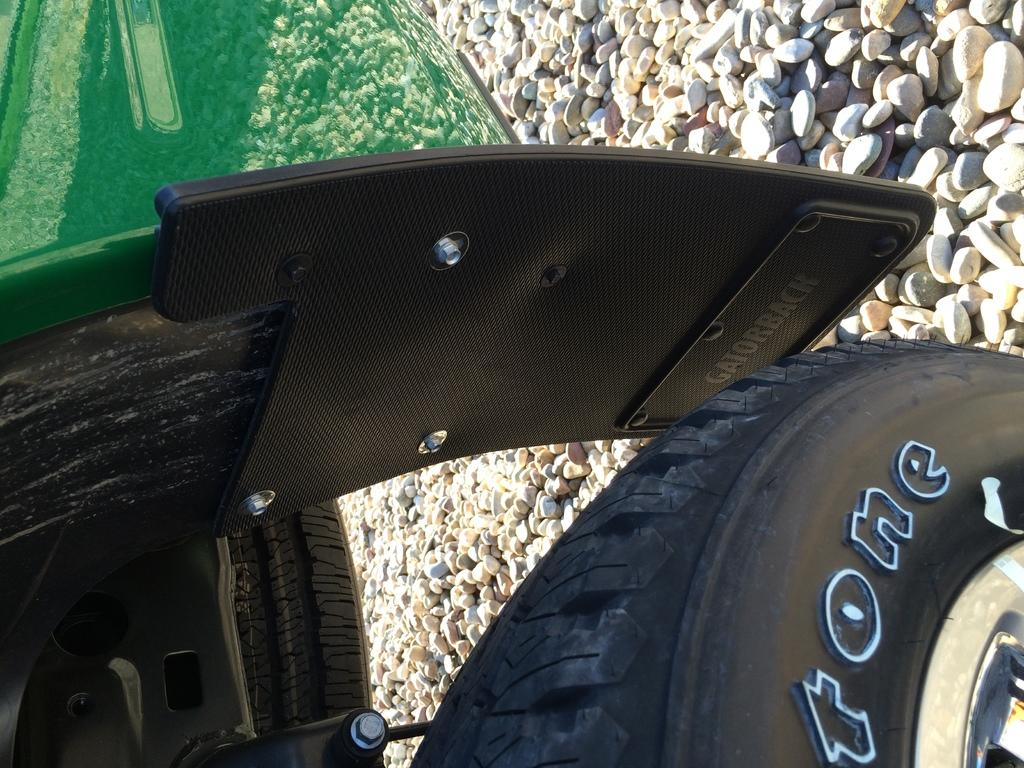What is the main subject of the image? There is a vehicle in the image. What is the vehicle resting on? The vehicle is on stones. Can you describe any specific part of the vehicle in the image? There is a tire on the right side of the image. What type of rabbit can be seen hopping near the vehicle in the image? There is no rabbit present in the image; it only features a vehicle on stones with a tire on the right side. 